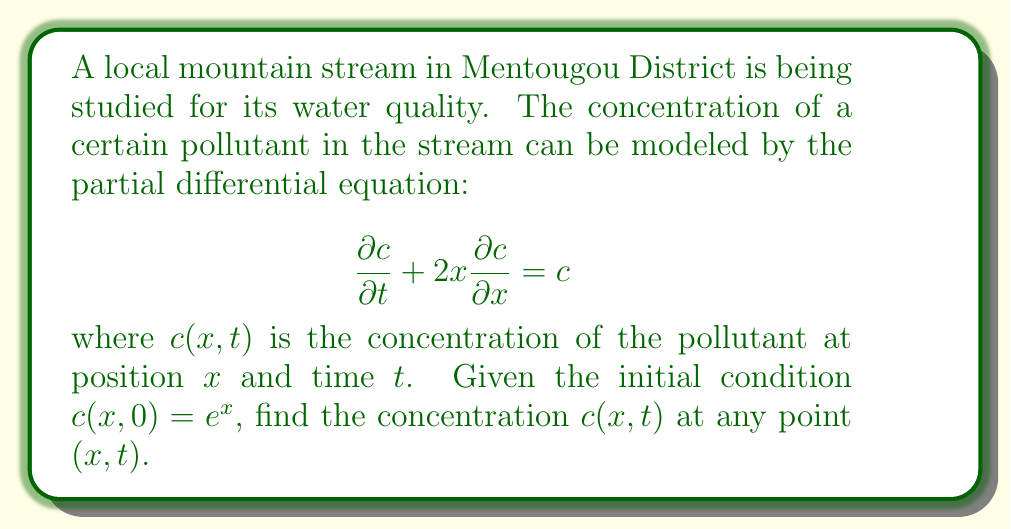Solve this math problem. Let's solve this first-order quasi-linear partial differential equation using the method of characteristics:

1) First, we write the characteristic equations:

   $$ \frac{dx}{dt} = 2x $$
   $$ \frac{dc}{dt} = c $$

2) Solve the first characteristic equation:
   $$ \frac{dx}{x} = 2dt $$
   Integrating both sides:
   $$ \ln|x| = 2t + k_1 $$
   $$ x = Ke^{2t}, \text{ where } K = e^{k_1} $$

3) Solve the second characteristic equation:
   $$ \frac{dc}{c} = dt $$
   Integrating:
   $$ \ln|c| = t + k_2 $$
   $$ c = Ce^t, \text{ where } C = e^{k_2} $$

4) The general solution is:
   $$ c = f(Ke^{-2t})e^t $$
   where $f$ is an arbitrary function.

5) Use the initial condition to find $f$:
   At $t=0$, $c(x,0) = e^x = f(x)$

6) Therefore, the solution is:
   $$ c(x,t) = e^{xe^{-2t}}e^t $$

This solution represents the concentration of the pollutant at any point $x$ and time $t$ in the stream.
Answer: $$ c(x,t) = e^{xe^{-2t}}e^t $$ 